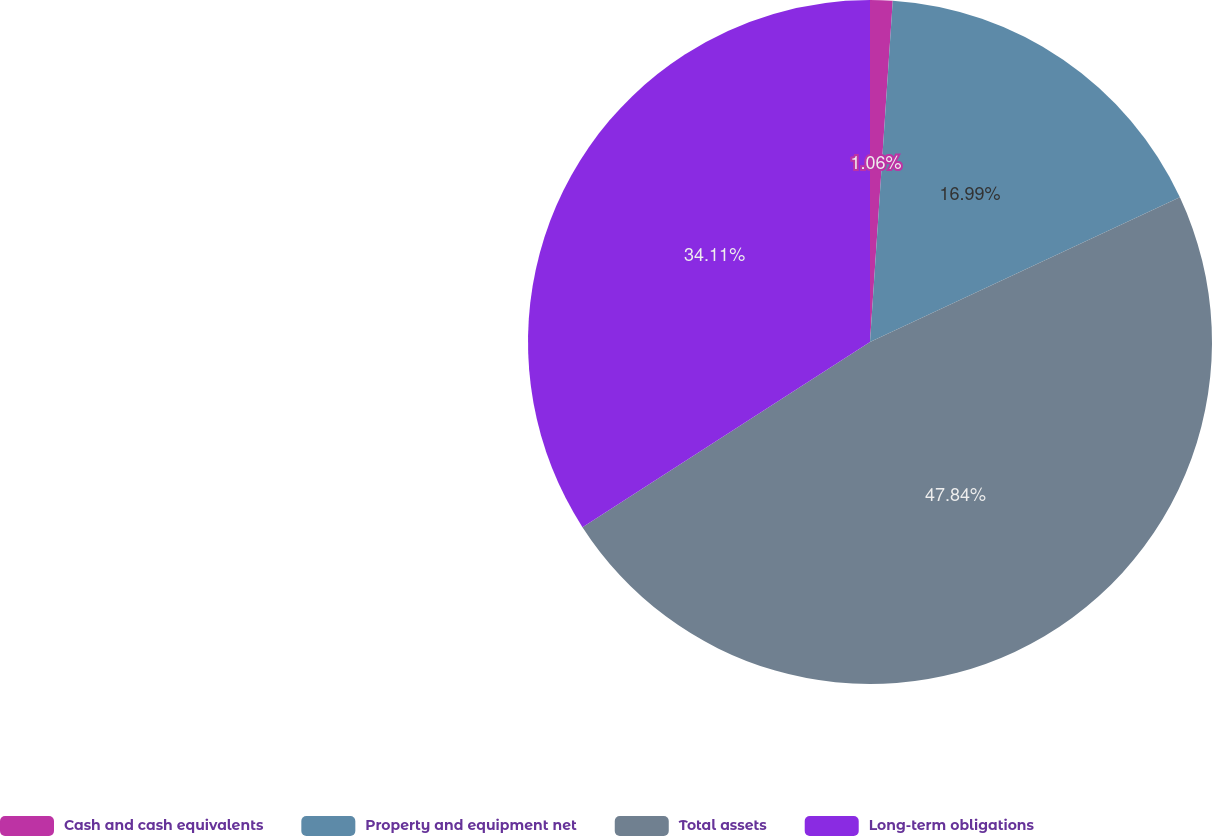<chart> <loc_0><loc_0><loc_500><loc_500><pie_chart><fcel>Cash and cash equivalents<fcel>Property and equipment net<fcel>Total assets<fcel>Long-term obligations<nl><fcel>1.06%<fcel>16.99%<fcel>47.85%<fcel>34.11%<nl></chart> 